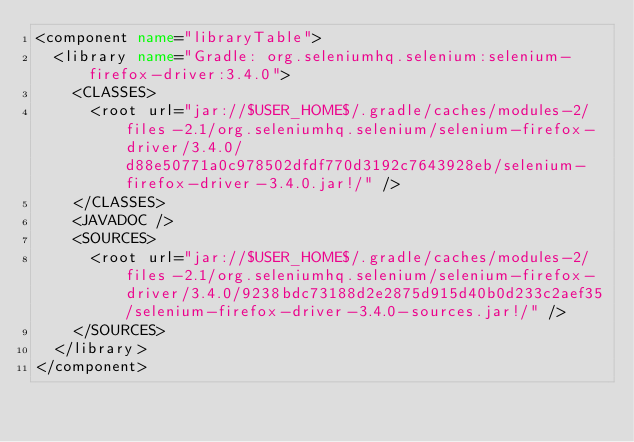Convert code to text. <code><loc_0><loc_0><loc_500><loc_500><_XML_><component name="libraryTable">
  <library name="Gradle: org.seleniumhq.selenium:selenium-firefox-driver:3.4.0">
    <CLASSES>
      <root url="jar://$USER_HOME$/.gradle/caches/modules-2/files-2.1/org.seleniumhq.selenium/selenium-firefox-driver/3.4.0/d88e50771a0c978502dfdf770d3192c7643928eb/selenium-firefox-driver-3.4.0.jar!/" />
    </CLASSES>
    <JAVADOC />
    <SOURCES>
      <root url="jar://$USER_HOME$/.gradle/caches/modules-2/files-2.1/org.seleniumhq.selenium/selenium-firefox-driver/3.4.0/9238bdc73188d2e2875d915d40b0d233c2aef35/selenium-firefox-driver-3.4.0-sources.jar!/" />
    </SOURCES>
  </library>
</component></code> 